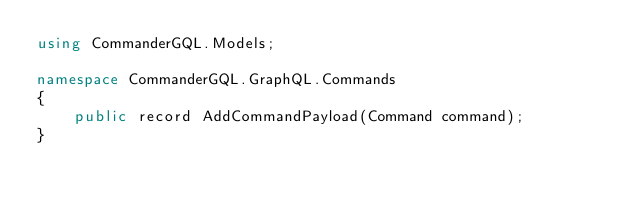<code> <loc_0><loc_0><loc_500><loc_500><_C#_>using CommanderGQL.Models;

namespace CommanderGQL.GraphQL.Commands
{
    public record AddCommandPayload(Command command);
}</code> 